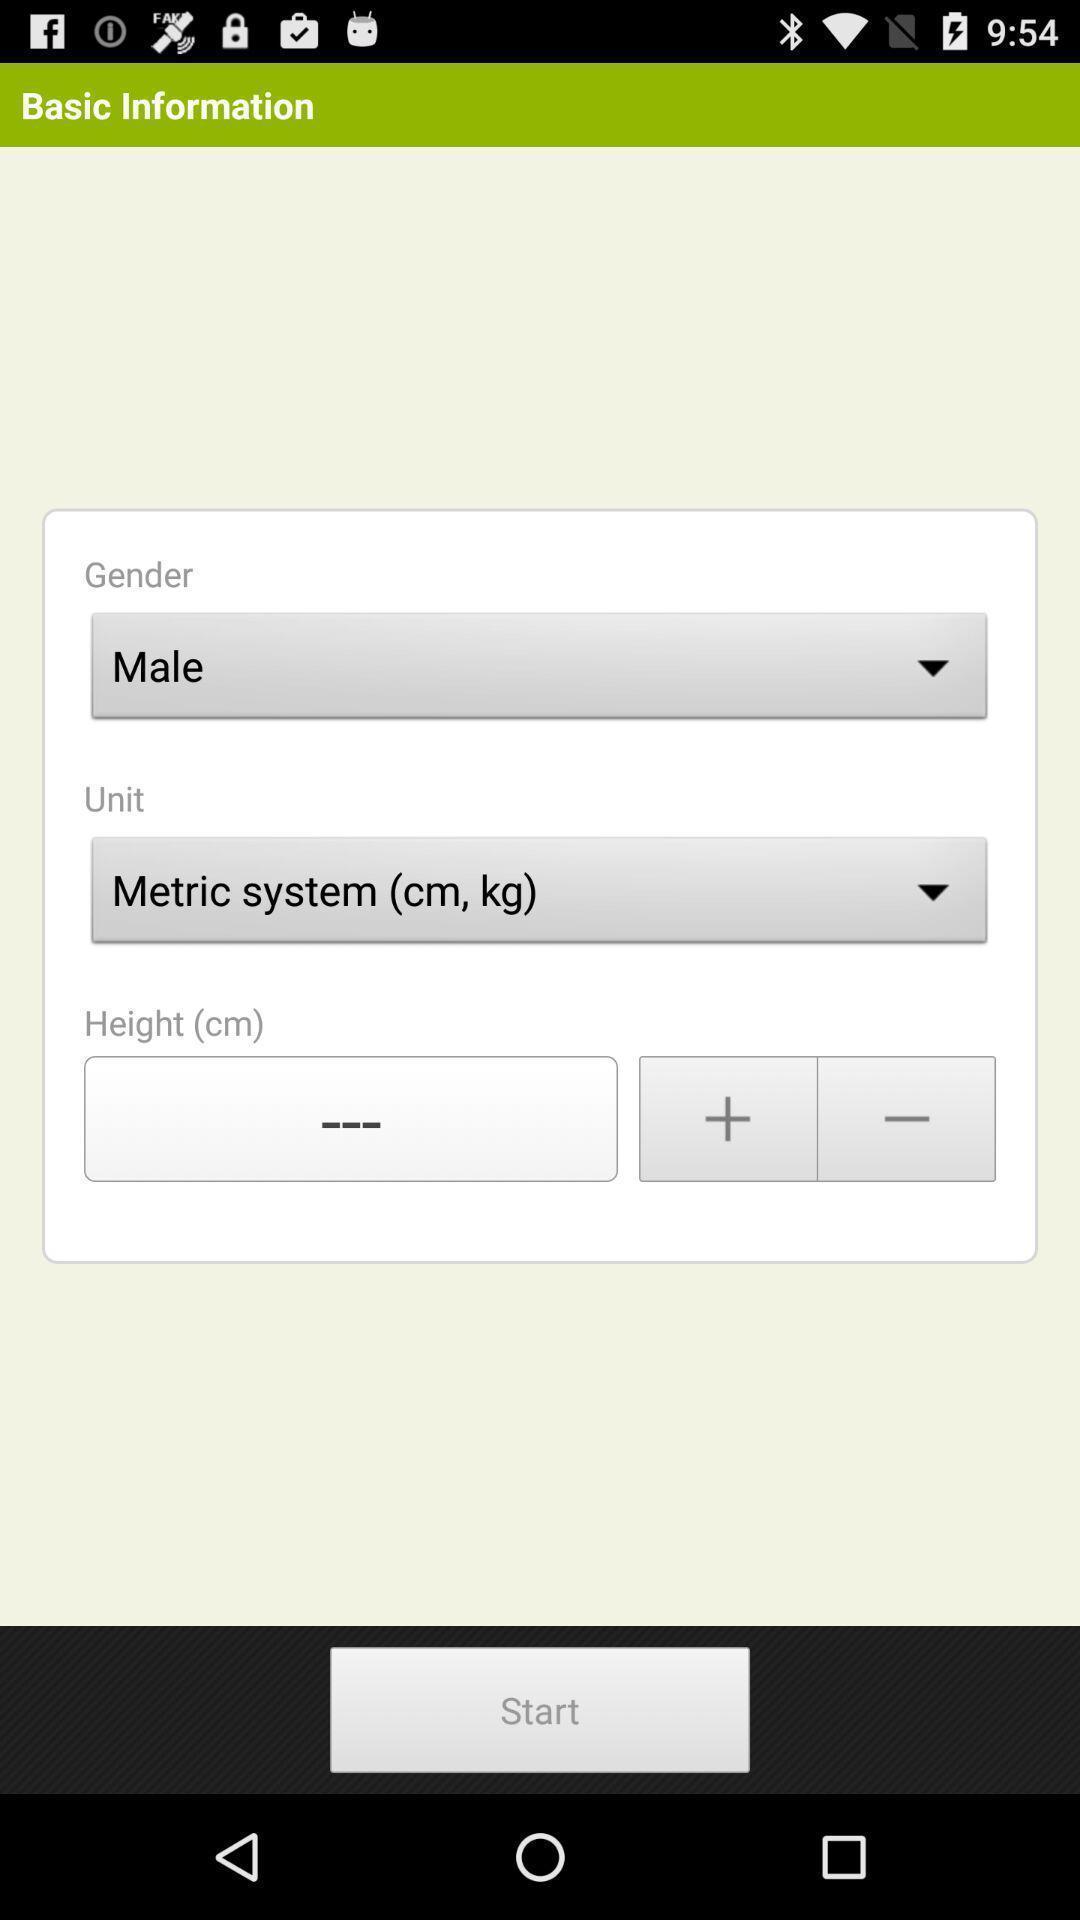Describe the content in this image. Page displaying the basic informations of an a app. 